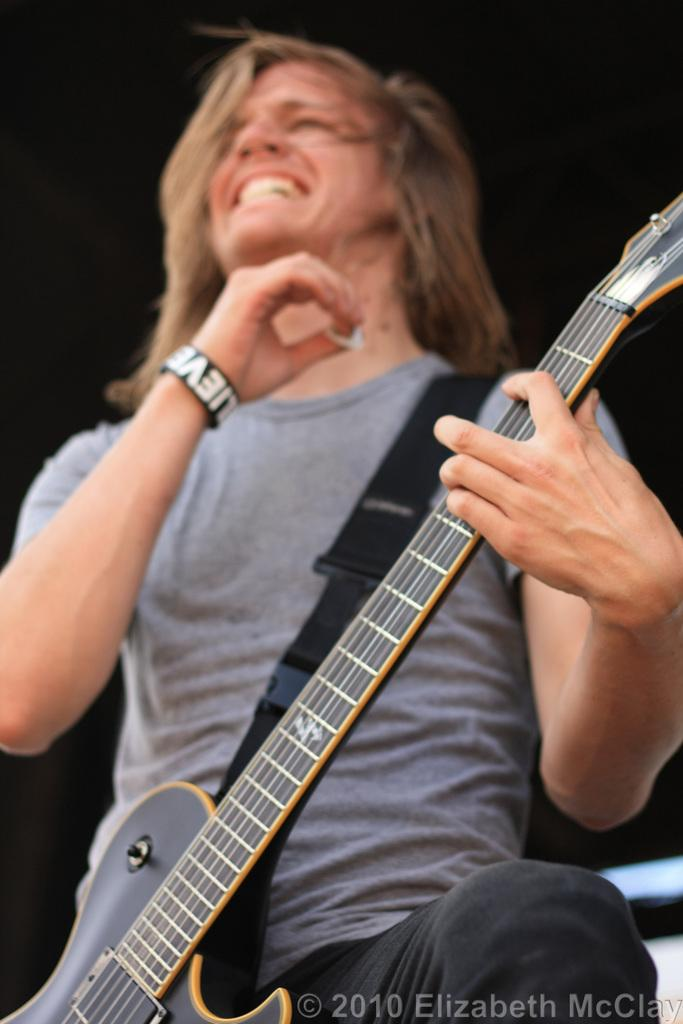What is the man in the image holding? The man is holding a guitar in the image. What feature of the guitar is mentioned in the facts? The guitar has a strap. How is the man's expression in the image? The man is smiling in the image. What can be said about the lighting in the image? The background of the image is dark. Is the man applying honey to his wound in the image? There is no mention of honey or a wound in the image, and the man is holding a guitar, not tending to any injury. 